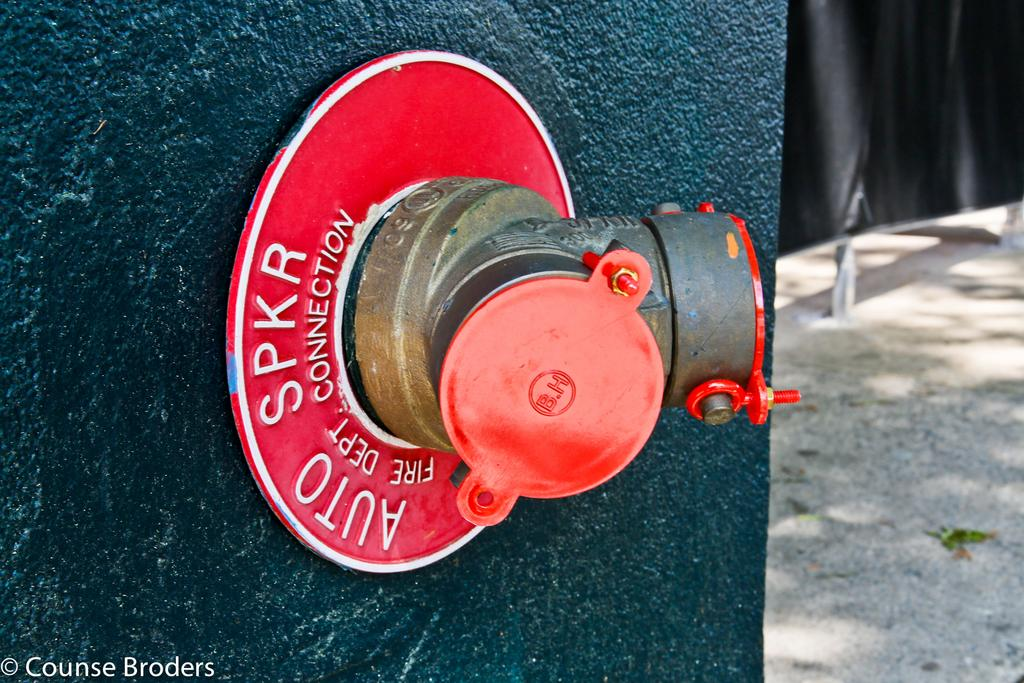What is the main object in the image? There is a metal pipe with lids in the image. Where is the metal pipe located? The metal pipe is on a wall. What can be seen in the background of the image? The ground is visible in the background of the image. How does the metal pipe say good-bye in the image? The metal pipe does not say good-bye in the image, as it is an inanimate object and cannot speak or express emotions. 